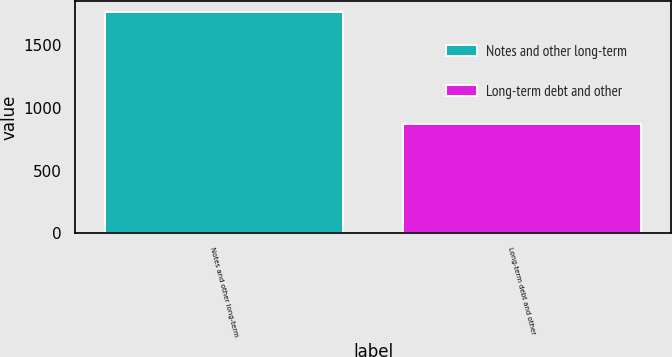Convert chart to OTSL. <chart><loc_0><loc_0><loc_500><loc_500><bar_chart><fcel>Notes and other long-term<fcel>Long-term debt and other<nl><fcel>1770<fcel>875<nl></chart> 